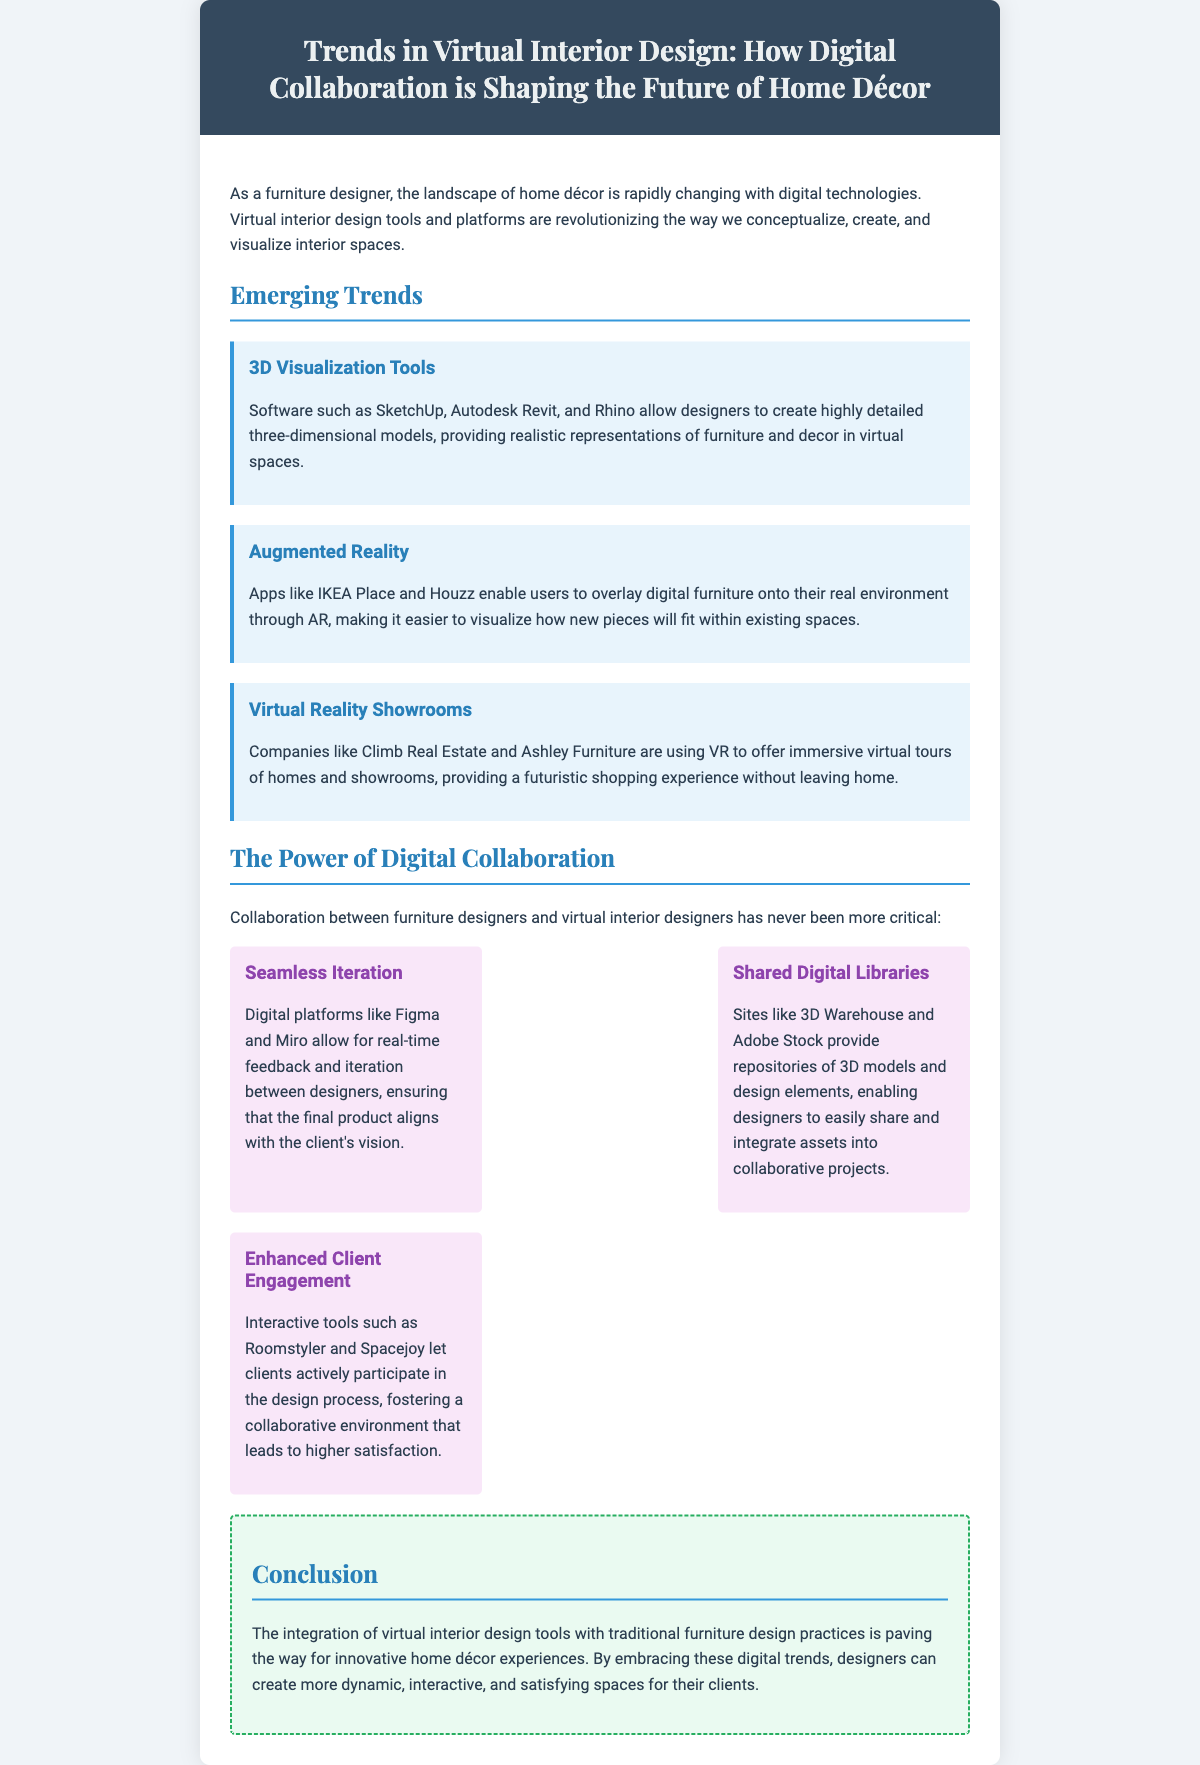what are the three emerging trends in virtual interior design? The trends mentioned are 3D Visualization Tools, Augmented Reality, and Virtual Reality Showrooms.
Answer: 3D Visualization Tools, Augmented Reality, Virtual Reality Showrooms what is a benefit of using SketchUp, Autodesk Revit, and Rhino? These software programs allow designers to create highly detailed three-dimensional models.
Answer: Highly detailed three-dimensional models which app enables users to overlay digital furniture onto real environments? The document specifically mentions apps like IKEA Place and Houzz for this feature.
Answer: IKEA Place, Houzz what digital platforms facilitate seamless iteration between designers? The document cites Figma and Miro as platforms that allow for real-time feedback and iteration.
Answer: Figma, Miro how do interactive tools like Roomstyler benefit designers? They allow clients to actively participate in the design process, enhancing client engagement.
Answer: Enhanced client engagement what does the conclusion highlight about virtual interior design tools? The conclusion emphasizes that these tools are paving the way for innovative home décor experiences.
Answer: Innovative home décor experiences how does augmented reality impact furniture visualization? It makes it easier for users to visualize how new pieces will fit within existing spaces.
Answer: Easier visualization what kind of libraries do sites like 3D Warehouse and Adobe Stock provide? They provide shared digital libraries of 3D models and design elements for designers.
Answer: Shared digital libraries of 3D models and design elements 